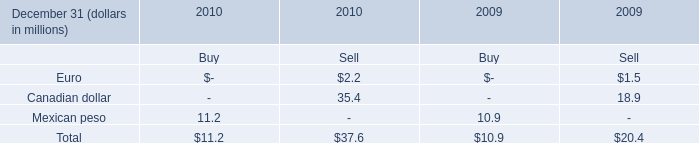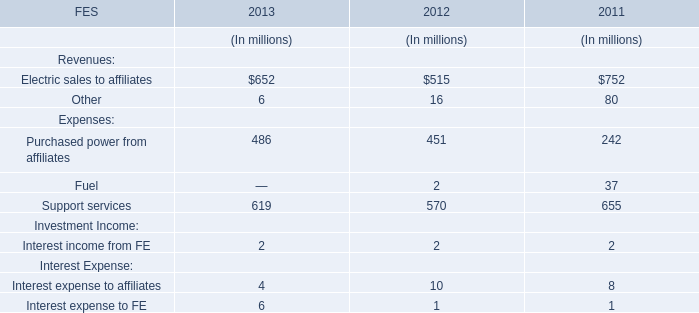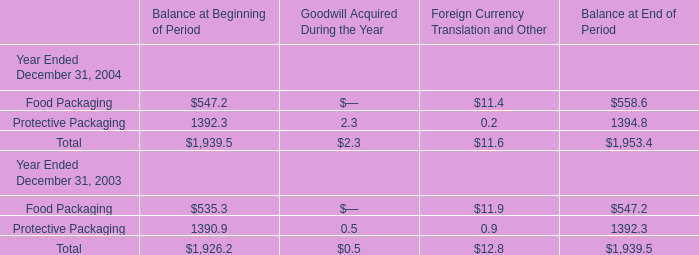In the year with largest amount of Purchased power from affiliates for Expenses, what's the sum of Balance at Beginning of Period? 
Computations: (535.3 + 1390.9)
Answer: 1926.2. 